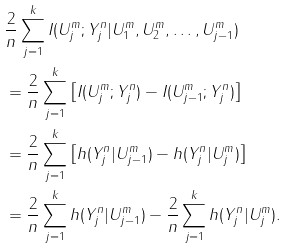Convert formula to latex. <formula><loc_0><loc_0><loc_500><loc_500>& \frac { 2 } { n } \sum _ { j = 1 } ^ { k } I ( U ^ { m } _ { j } ; Y ^ { n } _ { j } | U ^ { m } _ { 1 } , U ^ { m } _ { 2 } , \dots , U ^ { m } _ { j - 1 } ) \\ & = \frac { 2 } { n } \sum _ { j = 1 } ^ { k } \left [ I ( U ^ { m } _ { j } ; Y ^ { n } _ { j } ) - I ( U ^ { m } _ { j - 1 } ; Y ^ { n } _ { j } ) \right ] \\ & = \frac { 2 } { n } \sum _ { j = 1 } ^ { k } \left [ h ( Y ^ { n } _ { j } | U ^ { m } _ { j - 1 } ) - h ( Y ^ { n } _ { j } | U ^ { m } _ { j } ) \right ] \\ & = \frac { 2 } { n } \sum _ { j = 1 } ^ { k } h ( Y ^ { n } _ { j } | U ^ { m } _ { j - 1 } ) - \frac { 2 } { n } \sum _ { j = 1 } ^ { k } h ( Y ^ { n } _ { j } | U ^ { m } _ { j } ) .</formula> 